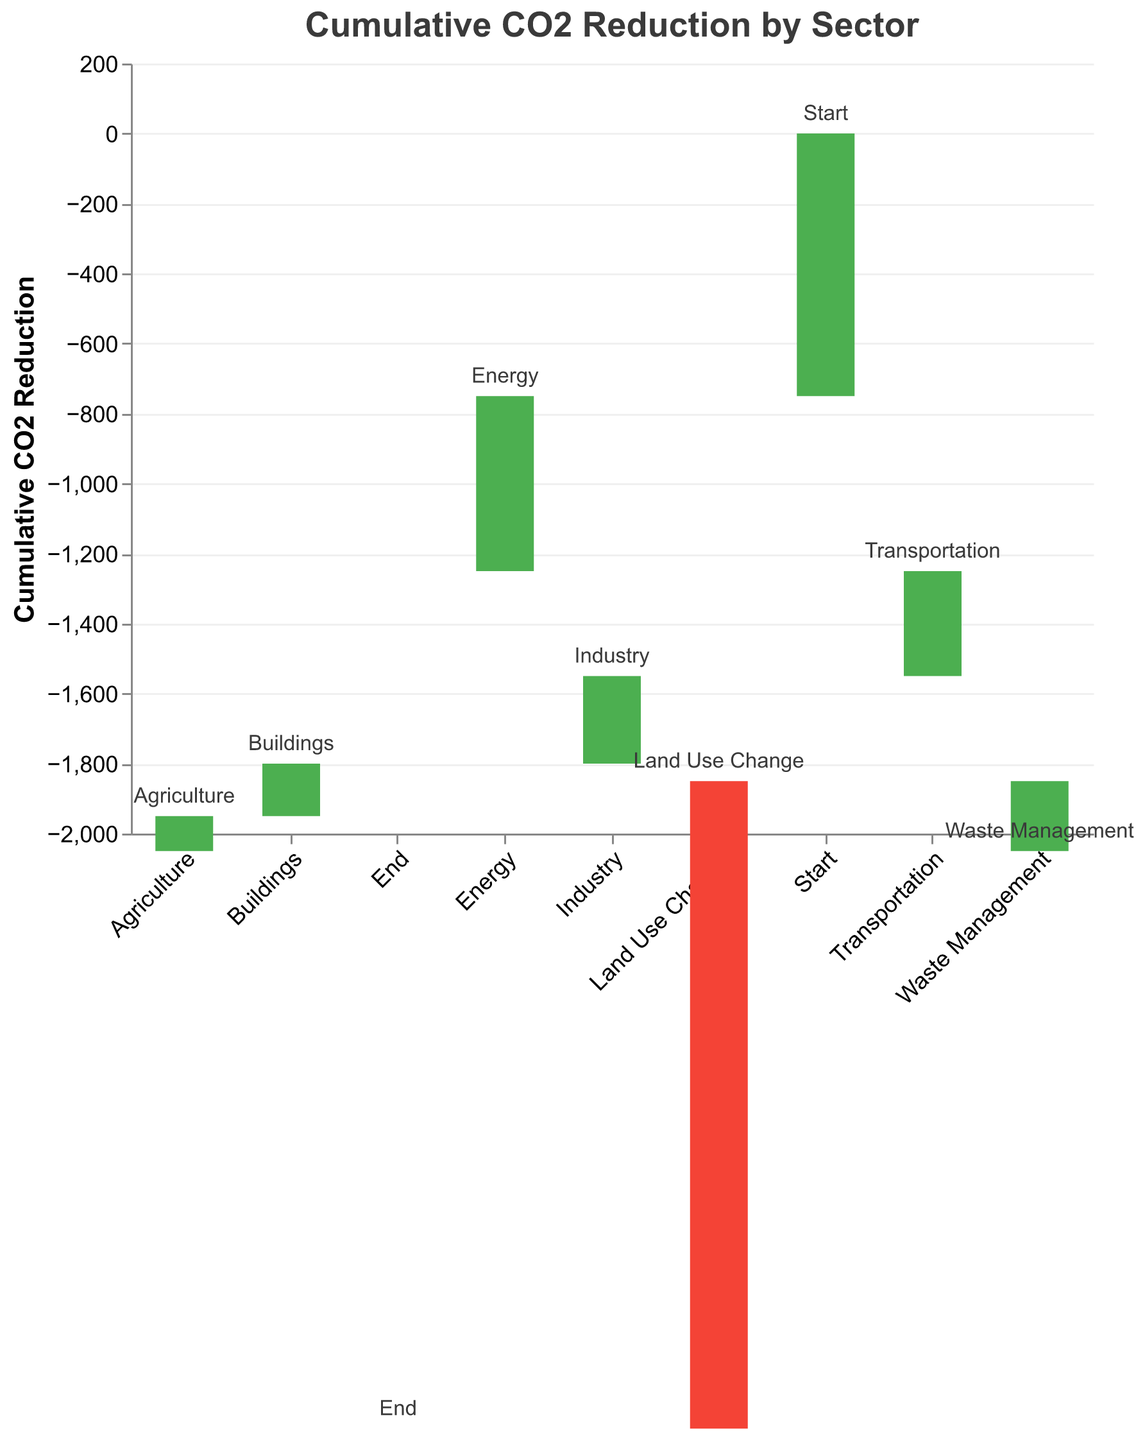What is the title of the figure? The title is displayed at the top of the chart and reads "Cumulative CO2 Reduction by Sector".
Answer: Cumulative CO2 Reduction by Sector What is the cumulative CO2 reduction for the Transportation sector? The bar for the Transportation sector is labeled with a reduction value of -500.
Answer: -500 Which sector contributes positively to CO2 levels? The sector showing a positive CO2 value (indicated by a bar that is not colored like the others) is "Land Use Change" with +200.
Answer: Land Use Change What is the total cumulative CO2 reduction indicated in the chart? The total cumulative CO2 reduction shown at the "End" is -1850.
Answer: -1850 How does the CO2 reduction from the Industry sector compare to the Buildings sector? The Industry sector has a reduction of -300 CO2, while the Buildings sector has -250 CO2. Industry contributes more.
Answer: Industry contributes more Calculate the total CO2 reduction from the Energy and Transportation sectors combined. Energy contributes -750 and Transportation contributes -500. The combined reduction is -750 + -500 = -1250.
Answer: -1250 Which sectors have a higher reduction in CO2 compared to the Agriculture sector? Sectors with higher reductions than Agriculture (-150) are Energy (-750), Transportation (-500), Industry (-300), and Buildings (-250).
Answer: Energy, Transportation, Industry, Buildings Does Waste Management or Land Use Change have a greater impact on CO2 reduction? Waste Management has a reduction impact of -100, while Land Use Change has a positive contribution of +200. Waste Management has a greater reduction impact.
Answer: Waste Management How much CO2 reduction is accounted for by Waste Management and Agriculture together? Waste Management reduces by -100 and Agriculture by -150. The total reduction is -100 + -150 = -250.
Answer: -250 